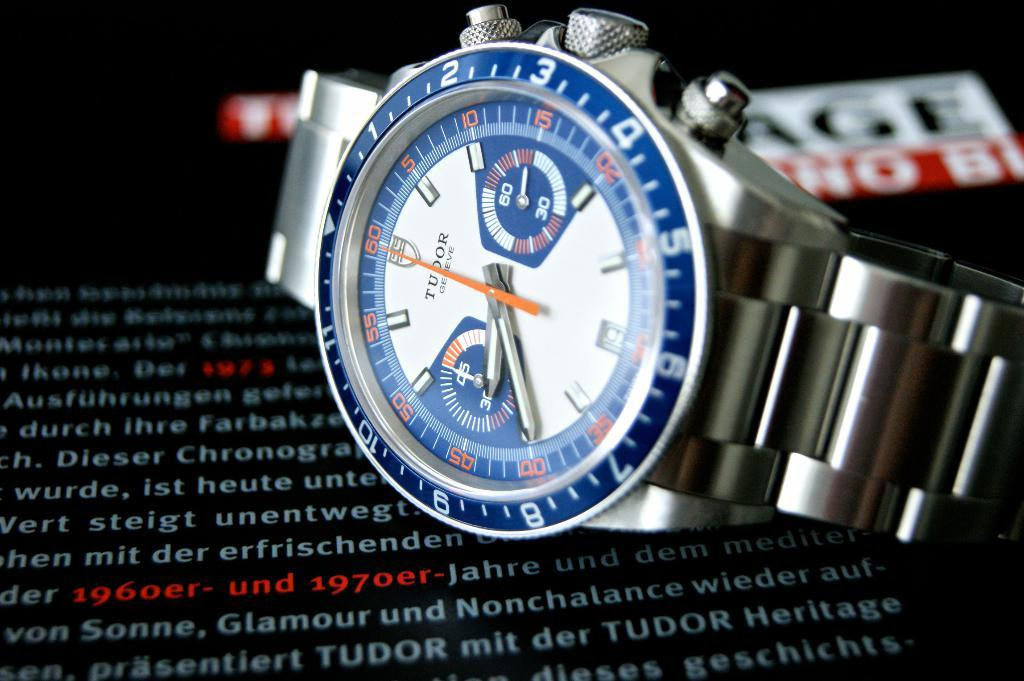<image>
Provide a brief description of the given image. Tudor Geneve metal watch with metal straps and three winding buttons on side of face. 